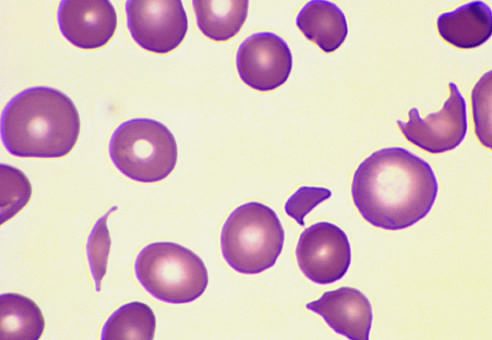does this specimen from a patient with hemolytic uremic syndrome contain several fragmented red cells?
Answer the question using a single word or phrase. Yes 